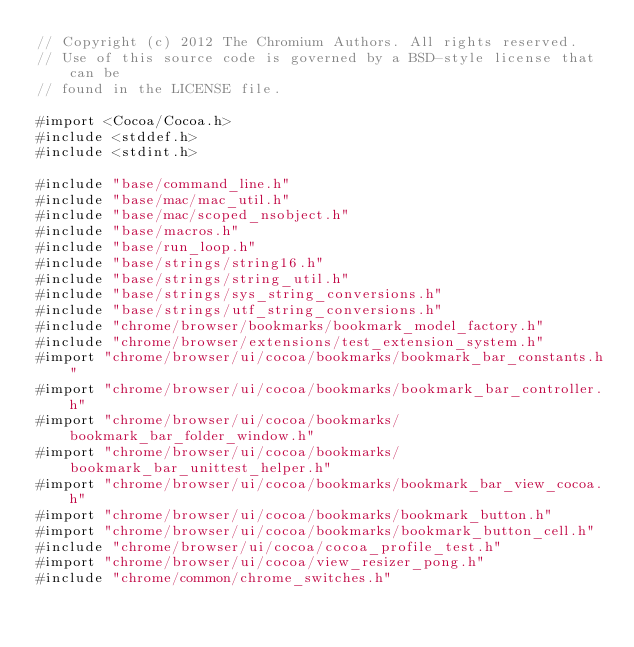Convert code to text. <code><loc_0><loc_0><loc_500><loc_500><_ObjectiveC_>// Copyright (c) 2012 The Chromium Authors. All rights reserved.
// Use of this source code is governed by a BSD-style license that can be
// found in the LICENSE file.

#import <Cocoa/Cocoa.h>
#include <stddef.h>
#include <stdint.h>

#include "base/command_line.h"
#include "base/mac/mac_util.h"
#include "base/mac/scoped_nsobject.h"
#include "base/macros.h"
#include "base/run_loop.h"
#include "base/strings/string16.h"
#include "base/strings/string_util.h"
#include "base/strings/sys_string_conversions.h"
#include "base/strings/utf_string_conversions.h"
#include "chrome/browser/bookmarks/bookmark_model_factory.h"
#include "chrome/browser/extensions/test_extension_system.h"
#import "chrome/browser/ui/cocoa/bookmarks/bookmark_bar_constants.h"
#import "chrome/browser/ui/cocoa/bookmarks/bookmark_bar_controller.h"
#import "chrome/browser/ui/cocoa/bookmarks/bookmark_bar_folder_window.h"
#import "chrome/browser/ui/cocoa/bookmarks/bookmark_bar_unittest_helper.h"
#import "chrome/browser/ui/cocoa/bookmarks/bookmark_bar_view_cocoa.h"
#import "chrome/browser/ui/cocoa/bookmarks/bookmark_button.h"
#import "chrome/browser/ui/cocoa/bookmarks/bookmark_button_cell.h"
#include "chrome/browser/ui/cocoa/cocoa_profile_test.h"
#import "chrome/browser/ui/cocoa/view_resizer_pong.h"
#include "chrome/common/chrome_switches.h"</code> 